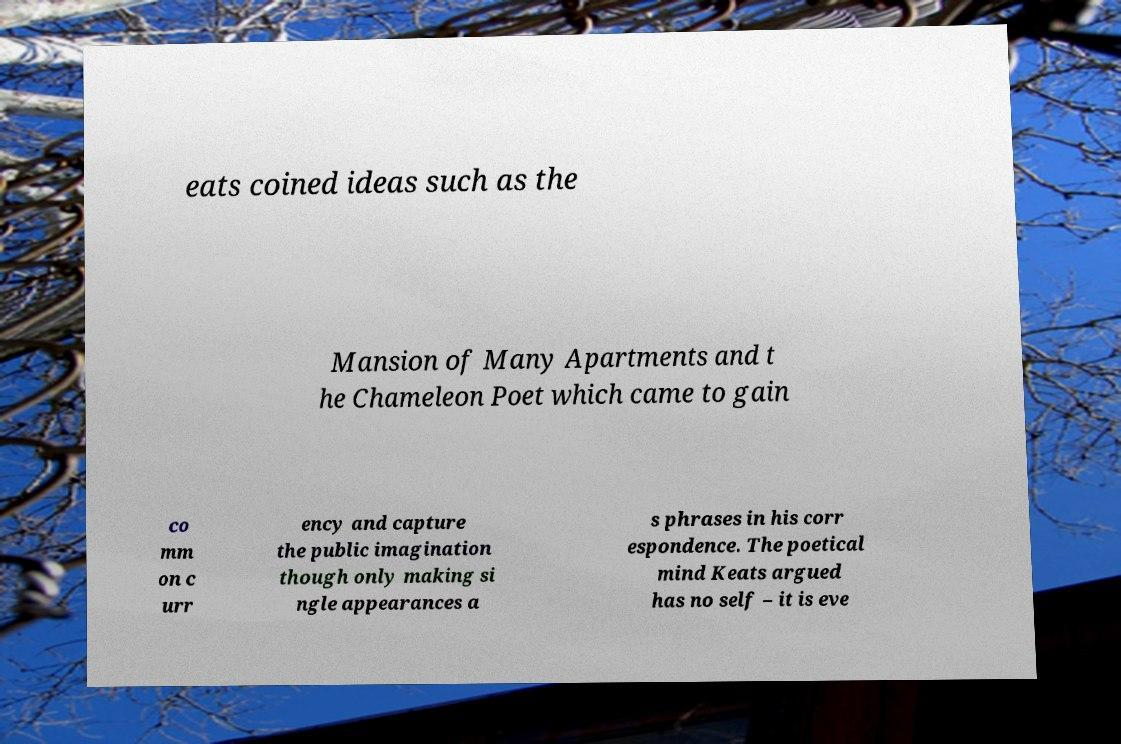Could you assist in decoding the text presented in this image and type it out clearly? eats coined ideas such as the Mansion of Many Apartments and t he Chameleon Poet which came to gain co mm on c urr ency and capture the public imagination though only making si ngle appearances a s phrases in his corr espondence. The poetical mind Keats argued has no self – it is eve 